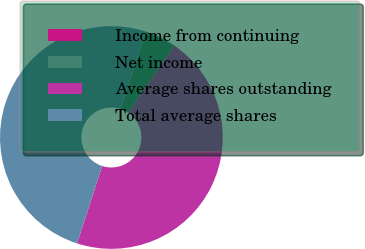Convert chart. <chart><loc_0><loc_0><loc_500><loc_500><pie_chart><fcel>Income from continuing<fcel>Net income<fcel>Average shares outstanding<fcel>Total average shares<nl><fcel>0.0%<fcel>4.55%<fcel>45.45%<fcel>50.0%<nl></chart> 